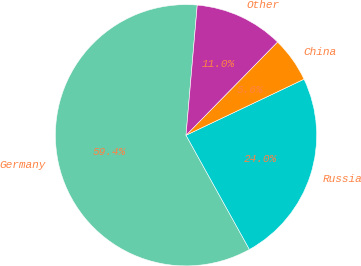Convert chart. <chart><loc_0><loc_0><loc_500><loc_500><pie_chart><fcel>Germany<fcel>Russia<fcel>China<fcel>Other<nl><fcel>59.43%<fcel>23.99%<fcel>5.59%<fcel>10.98%<nl></chart> 